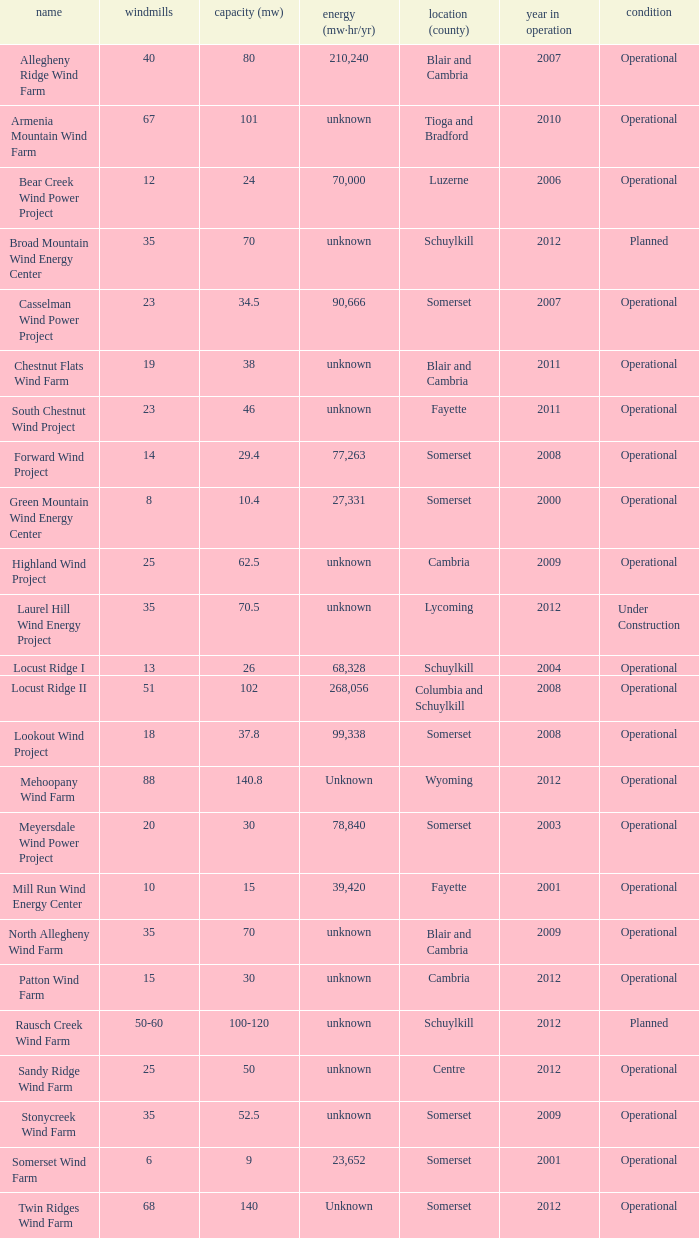What all turbines have a capacity of 30 and have a Somerset location? 20.0. 